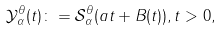<formula> <loc_0><loc_0><loc_500><loc_500>\mathcal { Y } _ { \alpha } ^ { \theta } ( t ) \colon = \mathcal { S } _ { \alpha } ^ { \theta } ( a t + B ( t ) ) , t > 0 ,</formula> 